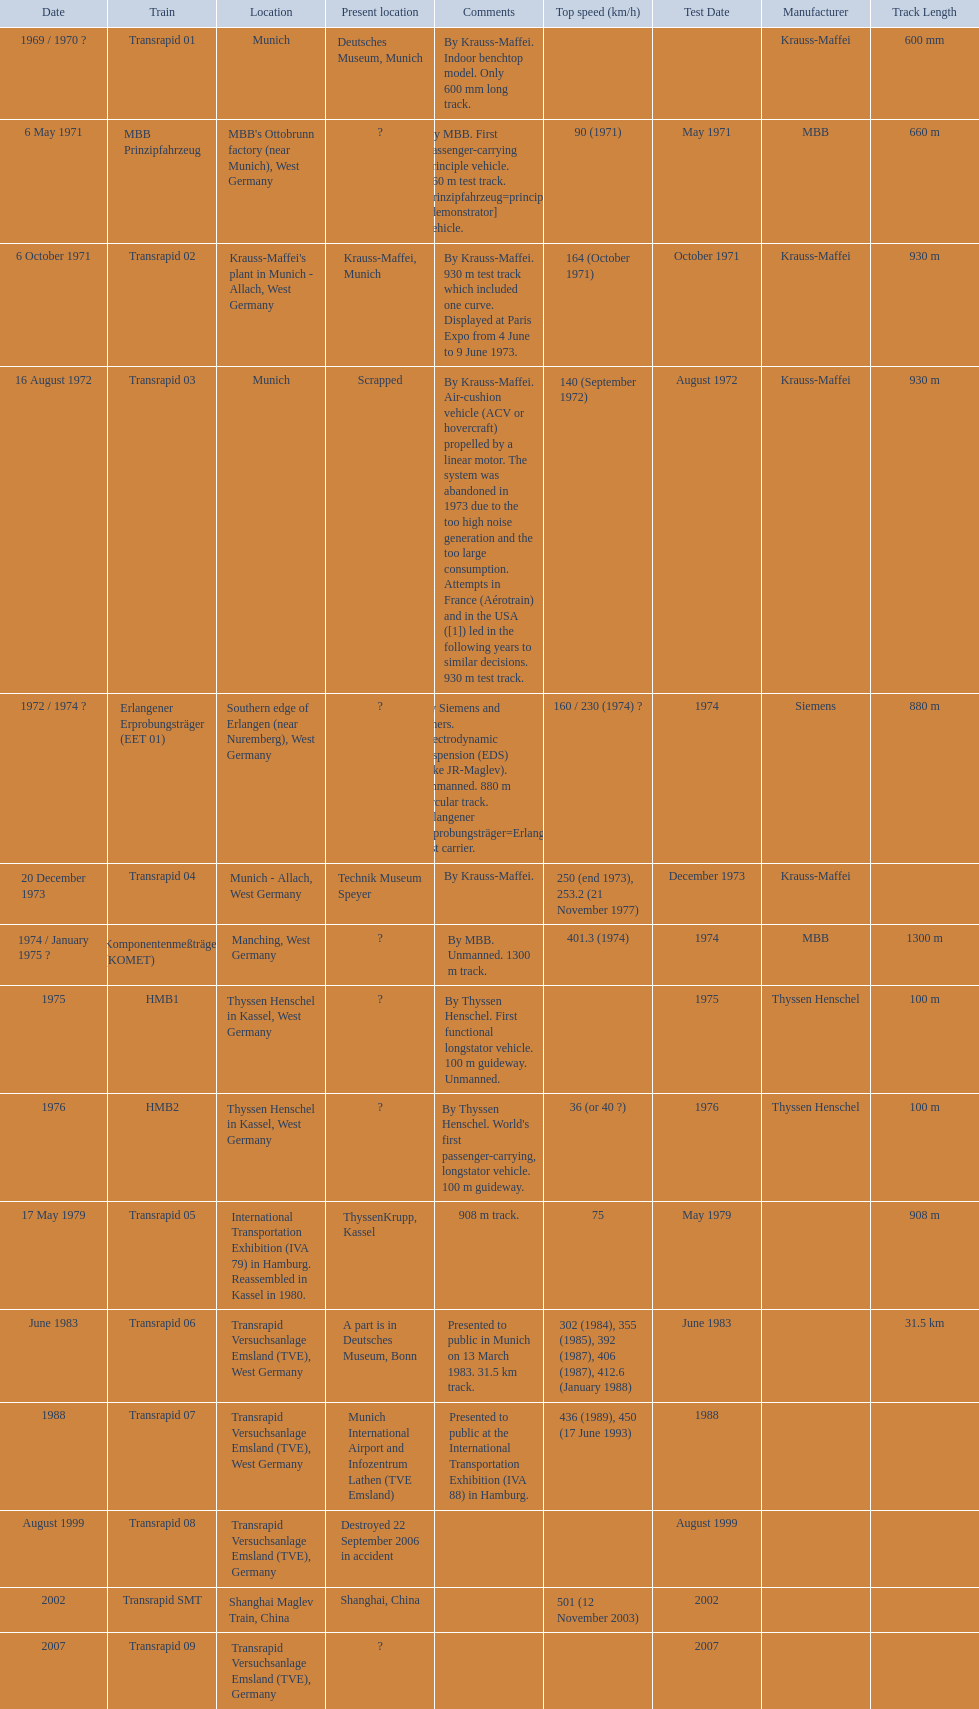What are all trains? Transrapid 01, MBB Prinzipfahrzeug, Transrapid 02, Transrapid 03, Erlangener Erprobungsträger (EET 01), Transrapid 04, Komponentenmeßträger (KOMET), HMB1, HMB2, Transrapid 05, Transrapid 06, Transrapid 07, Transrapid 08, Transrapid SMT, Transrapid 09. Which of all location of trains are known? Deutsches Museum, Munich, Krauss-Maffei, Munich, Scrapped, Technik Museum Speyer, ThyssenKrupp, Kassel, A part is in Deutsches Museum, Bonn, Munich International Airport and Infozentrum Lathen (TVE Emsland), Destroyed 22 September 2006 in accident, Shanghai, China. Which of those trains were scrapped? Transrapid 03. 